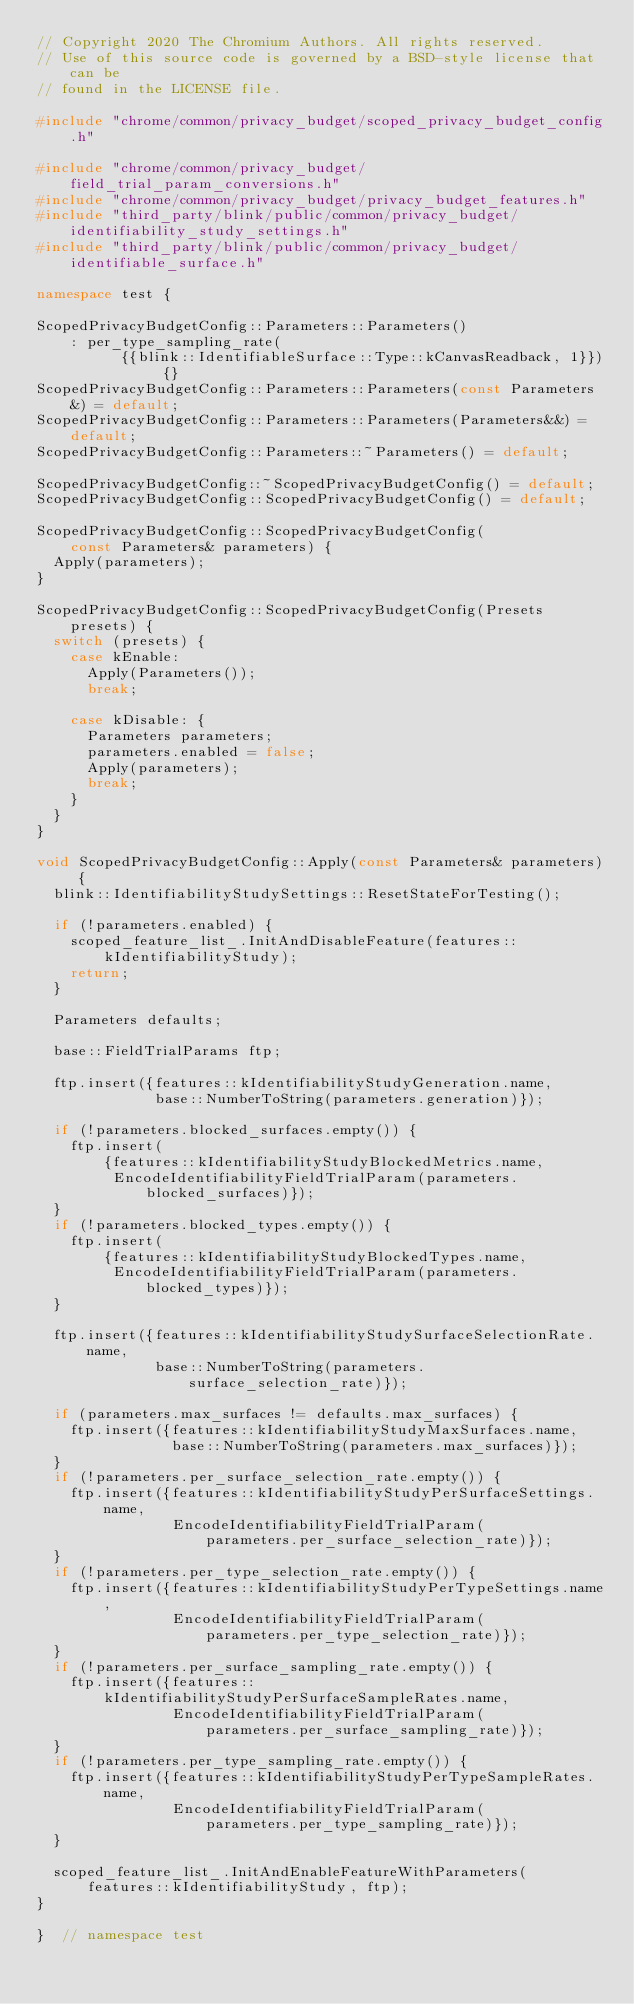<code> <loc_0><loc_0><loc_500><loc_500><_C++_>// Copyright 2020 The Chromium Authors. All rights reserved.
// Use of this source code is governed by a BSD-style license that can be
// found in the LICENSE file.

#include "chrome/common/privacy_budget/scoped_privacy_budget_config.h"

#include "chrome/common/privacy_budget/field_trial_param_conversions.h"
#include "chrome/common/privacy_budget/privacy_budget_features.h"
#include "third_party/blink/public/common/privacy_budget/identifiability_study_settings.h"
#include "third_party/blink/public/common/privacy_budget/identifiable_surface.h"

namespace test {

ScopedPrivacyBudgetConfig::Parameters::Parameters()
    : per_type_sampling_rate(
          {{blink::IdentifiableSurface::Type::kCanvasReadback, 1}}) {}
ScopedPrivacyBudgetConfig::Parameters::Parameters(const Parameters&) = default;
ScopedPrivacyBudgetConfig::Parameters::Parameters(Parameters&&) = default;
ScopedPrivacyBudgetConfig::Parameters::~Parameters() = default;

ScopedPrivacyBudgetConfig::~ScopedPrivacyBudgetConfig() = default;
ScopedPrivacyBudgetConfig::ScopedPrivacyBudgetConfig() = default;

ScopedPrivacyBudgetConfig::ScopedPrivacyBudgetConfig(
    const Parameters& parameters) {
  Apply(parameters);
}

ScopedPrivacyBudgetConfig::ScopedPrivacyBudgetConfig(Presets presets) {
  switch (presets) {
    case kEnable:
      Apply(Parameters());
      break;

    case kDisable: {
      Parameters parameters;
      parameters.enabled = false;
      Apply(parameters);
      break;
    }
  }
}

void ScopedPrivacyBudgetConfig::Apply(const Parameters& parameters) {
  blink::IdentifiabilityStudySettings::ResetStateForTesting();

  if (!parameters.enabled) {
    scoped_feature_list_.InitAndDisableFeature(features::kIdentifiabilityStudy);
    return;
  }

  Parameters defaults;

  base::FieldTrialParams ftp;

  ftp.insert({features::kIdentifiabilityStudyGeneration.name,
              base::NumberToString(parameters.generation)});

  if (!parameters.blocked_surfaces.empty()) {
    ftp.insert(
        {features::kIdentifiabilityStudyBlockedMetrics.name,
         EncodeIdentifiabilityFieldTrialParam(parameters.blocked_surfaces)});
  }
  if (!parameters.blocked_types.empty()) {
    ftp.insert(
        {features::kIdentifiabilityStudyBlockedTypes.name,
         EncodeIdentifiabilityFieldTrialParam(parameters.blocked_types)});
  }

  ftp.insert({features::kIdentifiabilityStudySurfaceSelectionRate.name,
              base::NumberToString(parameters.surface_selection_rate)});

  if (parameters.max_surfaces != defaults.max_surfaces) {
    ftp.insert({features::kIdentifiabilityStudyMaxSurfaces.name,
                base::NumberToString(parameters.max_surfaces)});
  }
  if (!parameters.per_surface_selection_rate.empty()) {
    ftp.insert({features::kIdentifiabilityStudyPerSurfaceSettings.name,
                EncodeIdentifiabilityFieldTrialParam(
                    parameters.per_surface_selection_rate)});
  }
  if (!parameters.per_type_selection_rate.empty()) {
    ftp.insert({features::kIdentifiabilityStudyPerTypeSettings.name,
                EncodeIdentifiabilityFieldTrialParam(
                    parameters.per_type_selection_rate)});
  }
  if (!parameters.per_surface_sampling_rate.empty()) {
    ftp.insert({features::kIdentifiabilityStudyPerSurfaceSampleRates.name,
                EncodeIdentifiabilityFieldTrialParam(
                    parameters.per_surface_sampling_rate)});
  }
  if (!parameters.per_type_sampling_rate.empty()) {
    ftp.insert({features::kIdentifiabilityStudyPerTypeSampleRates.name,
                EncodeIdentifiabilityFieldTrialParam(
                    parameters.per_type_sampling_rate)});
  }

  scoped_feature_list_.InitAndEnableFeatureWithParameters(
      features::kIdentifiabilityStudy, ftp);
}

}  // namespace test
</code> 